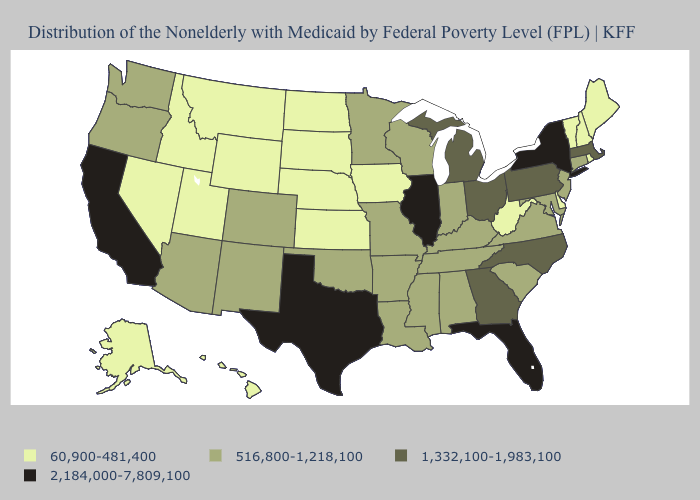What is the lowest value in states that border Texas?
Keep it brief. 516,800-1,218,100. What is the lowest value in states that border Illinois?
Answer briefly. 60,900-481,400. Which states have the highest value in the USA?
Give a very brief answer. California, Florida, Illinois, New York, Texas. Name the states that have a value in the range 60,900-481,400?
Answer briefly. Alaska, Delaware, Hawaii, Idaho, Iowa, Kansas, Maine, Montana, Nebraska, Nevada, New Hampshire, North Dakota, Rhode Island, South Dakota, Utah, Vermont, West Virginia, Wyoming. What is the highest value in the USA?
Short answer required. 2,184,000-7,809,100. What is the lowest value in the USA?
Keep it brief. 60,900-481,400. What is the value of Nevada?
Quick response, please. 60,900-481,400. What is the value of Arizona?
Concise answer only. 516,800-1,218,100. Name the states that have a value in the range 1,332,100-1,983,100?
Quick response, please. Georgia, Massachusetts, Michigan, North Carolina, Ohio, Pennsylvania. Among the states that border Kansas , which have the highest value?
Short answer required. Colorado, Missouri, Oklahoma. What is the lowest value in the USA?
Concise answer only. 60,900-481,400. Name the states that have a value in the range 1,332,100-1,983,100?
Be succinct. Georgia, Massachusetts, Michigan, North Carolina, Ohio, Pennsylvania. What is the value of South Dakota?
Concise answer only. 60,900-481,400. What is the value of Nevada?
Write a very short answer. 60,900-481,400. What is the highest value in states that border Wisconsin?
Keep it brief. 2,184,000-7,809,100. 